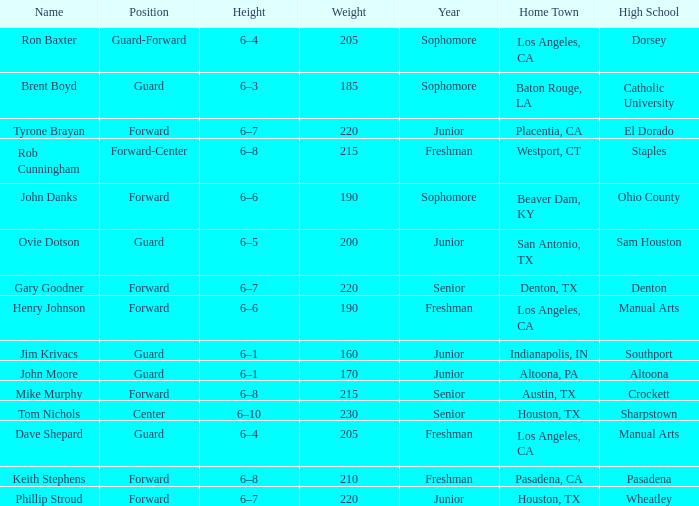What is the Home Town with a Year of freshman, and a Height with 6–6? Los Angeles, CA. Could you parse the entire table as a dict? {'header': ['Name', 'Position', 'Height', 'Weight', 'Year', 'Home Town', 'High School'], 'rows': [['Ron Baxter', 'Guard-Forward', '6–4', '205', 'Sophomore', 'Los Angeles, CA', 'Dorsey'], ['Brent Boyd', 'Guard', '6–3', '185', 'Sophomore', 'Baton Rouge, LA', 'Catholic University'], ['Tyrone Brayan', 'Forward', '6–7', '220', 'Junior', 'Placentia, CA', 'El Dorado'], ['Rob Cunningham', 'Forward-Center', '6–8', '215', 'Freshman', 'Westport, CT', 'Staples'], ['John Danks', 'Forward', '6–6', '190', 'Sophomore', 'Beaver Dam, KY', 'Ohio County'], ['Ovie Dotson', 'Guard', '6–5', '200', 'Junior', 'San Antonio, TX', 'Sam Houston'], ['Gary Goodner', 'Forward', '6–7', '220', 'Senior', 'Denton, TX', 'Denton'], ['Henry Johnson', 'Forward', '6–6', '190', 'Freshman', 'Los Angeles, CA', 'Manual Arts'], ['Jim Krivacs', 'Guard', '6–1', '160', 'Junior', 'Indianapolis, IN', 'Southport'], ['John Moore', 'Guard', '6–1', '170', 'Junior', 'Altoona, PA', 'Altoona'], ['Mike Murphy', 'Forward', '6–8', '215', 'Senior', 'Austin, TX', 'Crockett'], ['Tom Nichols', 'Center', '6–10', '230', 'Senior', 'Houston, TX', 'Sharpstown'], ['Dave Shepard', 'Guard', '6–4', '205', 'Freshman', 'Los Angeles, CA', 'Manual Arts'], ['Keith Stephens', 'Forward', '6–8', '210', 'Freshman', 'Pasadena, CA', 'Pasadena'], ['Phillip Stroud', 'Forward', '6–7', '220', 'Junior', 'Houston, TX', 'Wheatley']]} 